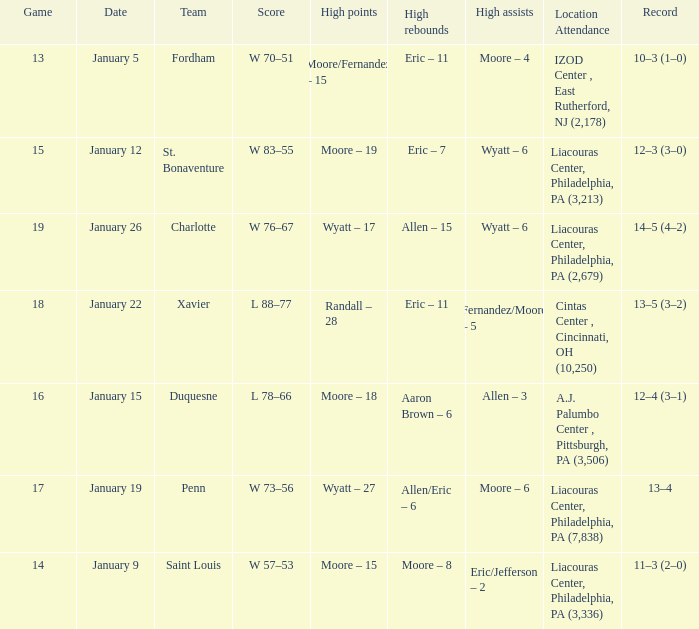Who had the most assists and how many did they have on January 5? Moore – 4. 